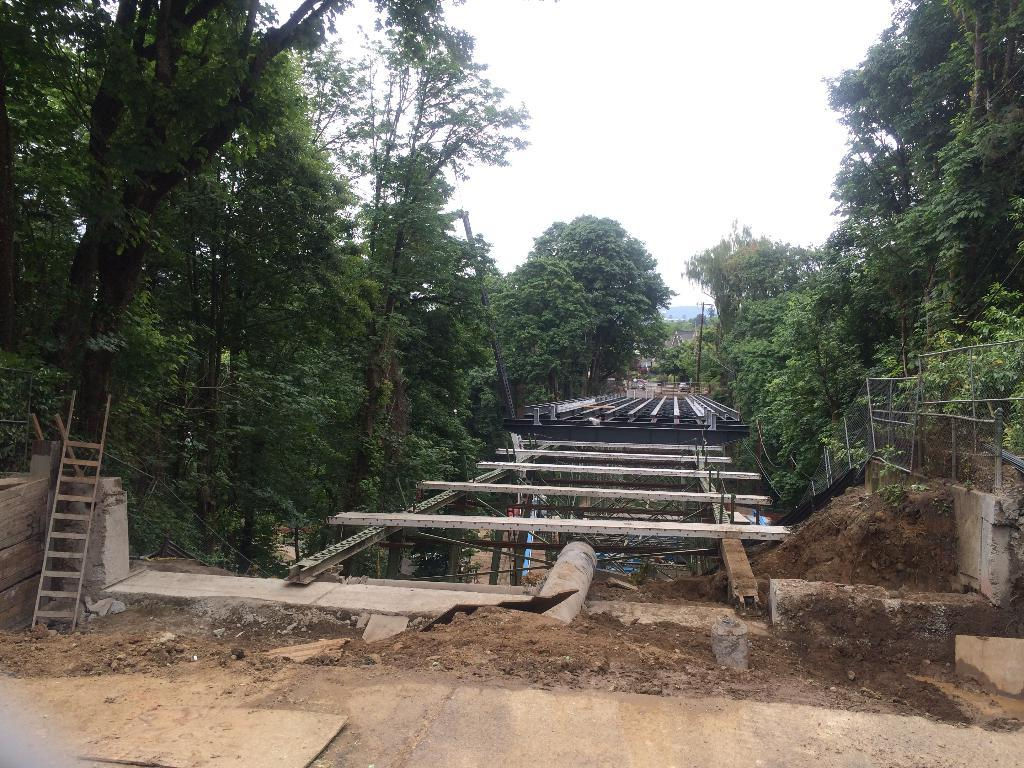What type of vegetation can be seen on both sides of the image? There are trees on the right side and the left side of the image. What is located at the center of the image? There is a metal structure at the center of the image. What can be seen in the background of the image? There is a sky visible in the background of the image. What type of straw is used to make the tin coach in the image? There is no straw or tin coach present in the image. What type of coach is driving the metal structure in the image? There is no coach or driving activity depicted in the image; it features trees, a metal structure, and a sky. 